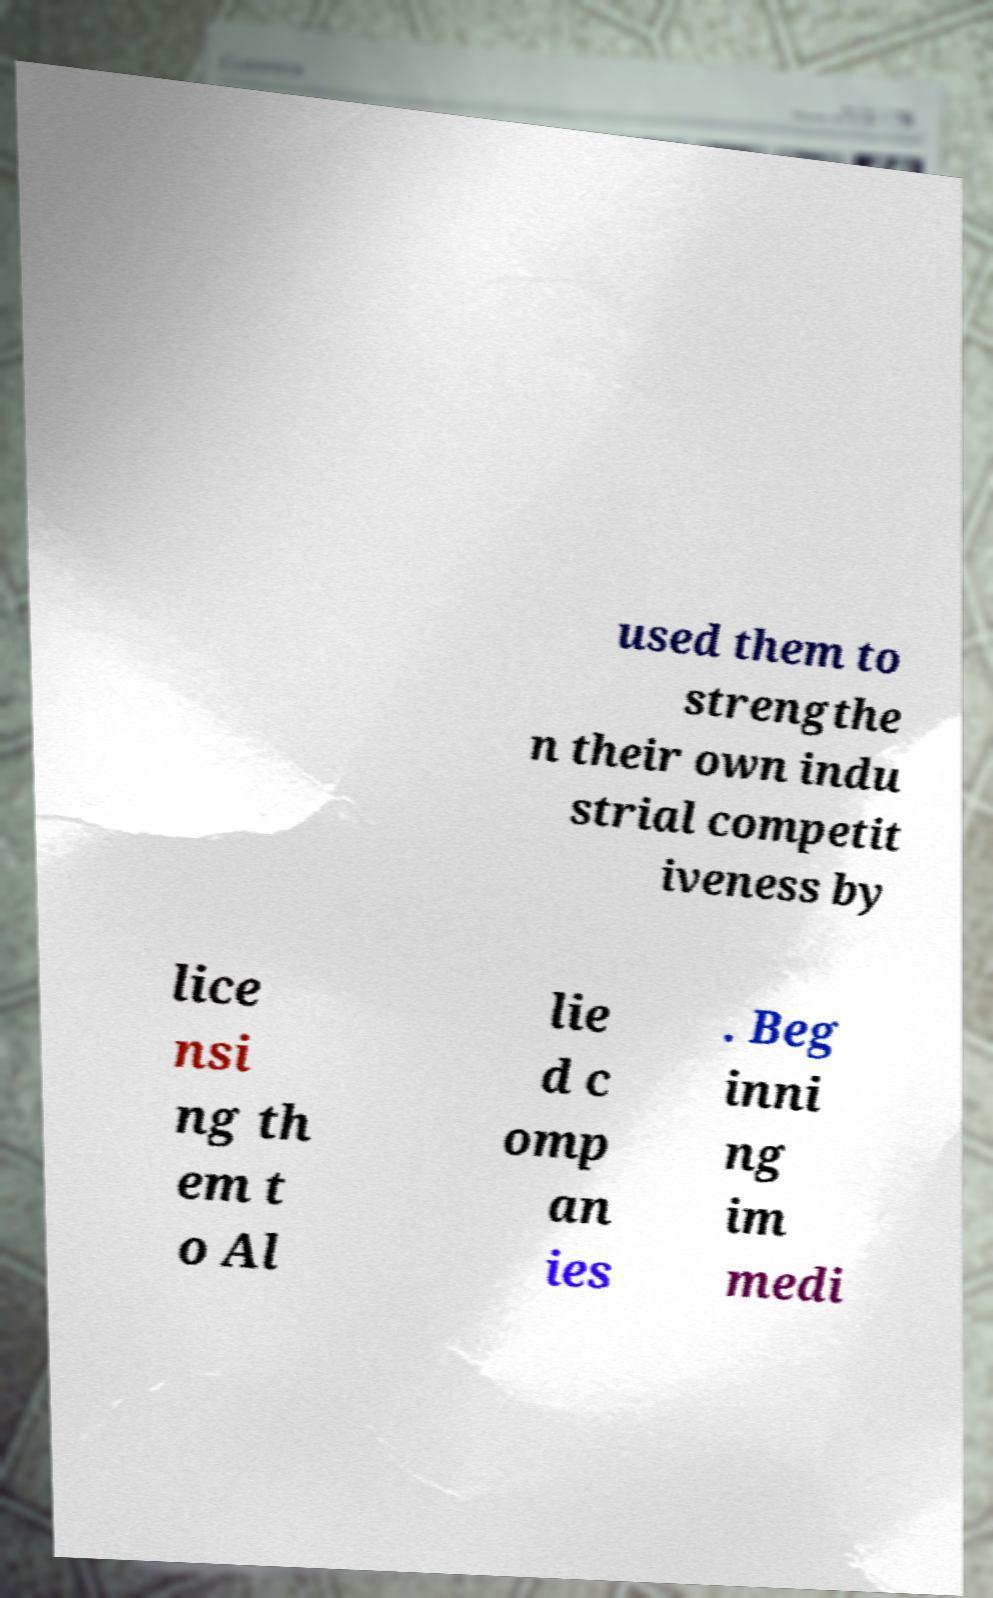There's text embedded in this image that I need extracted. Can you transcribe it verbatim? used them to strengthe n their own indu strial competit iveness by lice nsi ng th em t o Al lie d c omp an ies . Beg inni ng im medi 